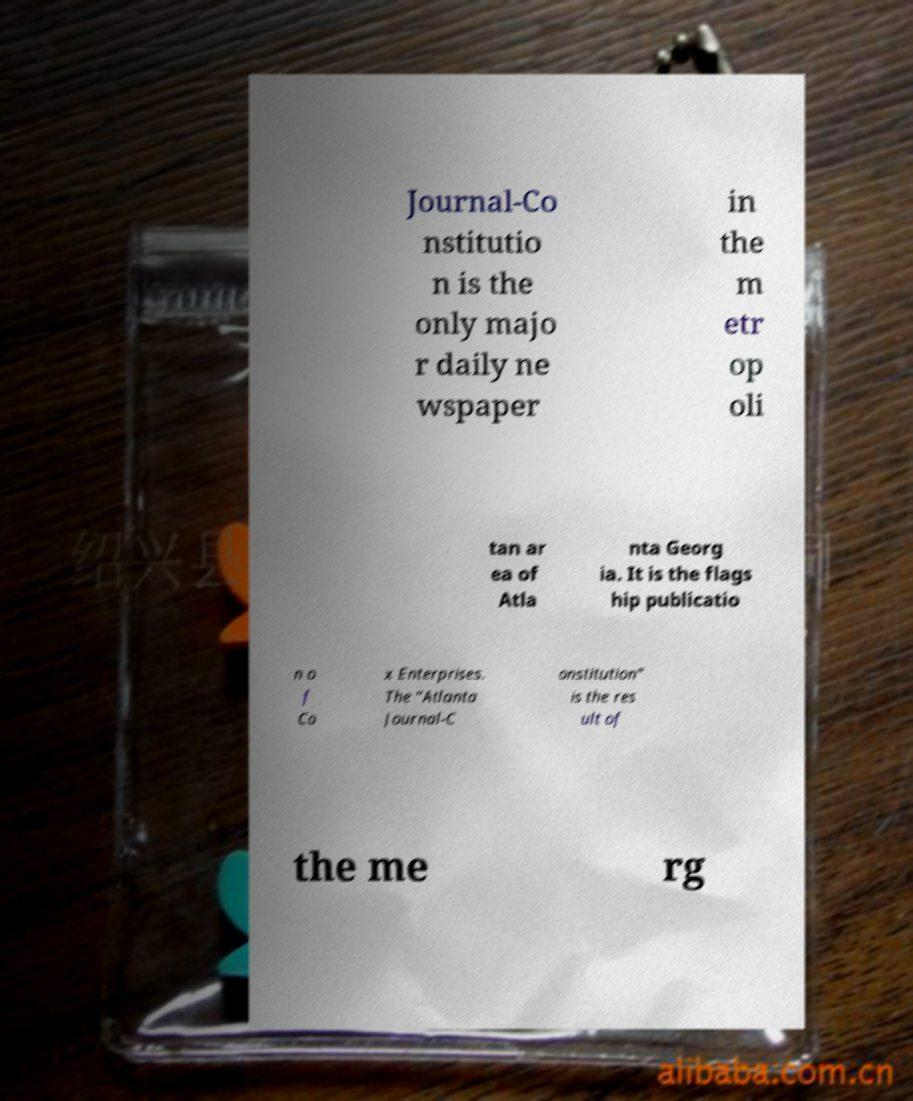Please identify and transcribe the text found in this image. Journal-Co nstitutio n is the only majo r daily ne wspaper in the m etr op oli tan ar ea of Atla nta Georg ia. It is the flags hip publicatio n o f Co x Enterprises. The "Atlanta Journal-C onstitution" is the res ult of the me rg 